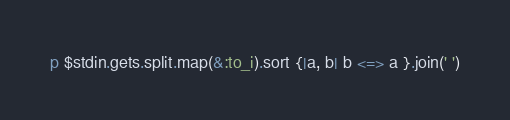<code> <loc_0><loc_0><loc_500><loc_500><_Ruby_>p $stdin.gets.split.map(&:to_i).sort {|a, b| b <=> a }.join(' ')</code> 